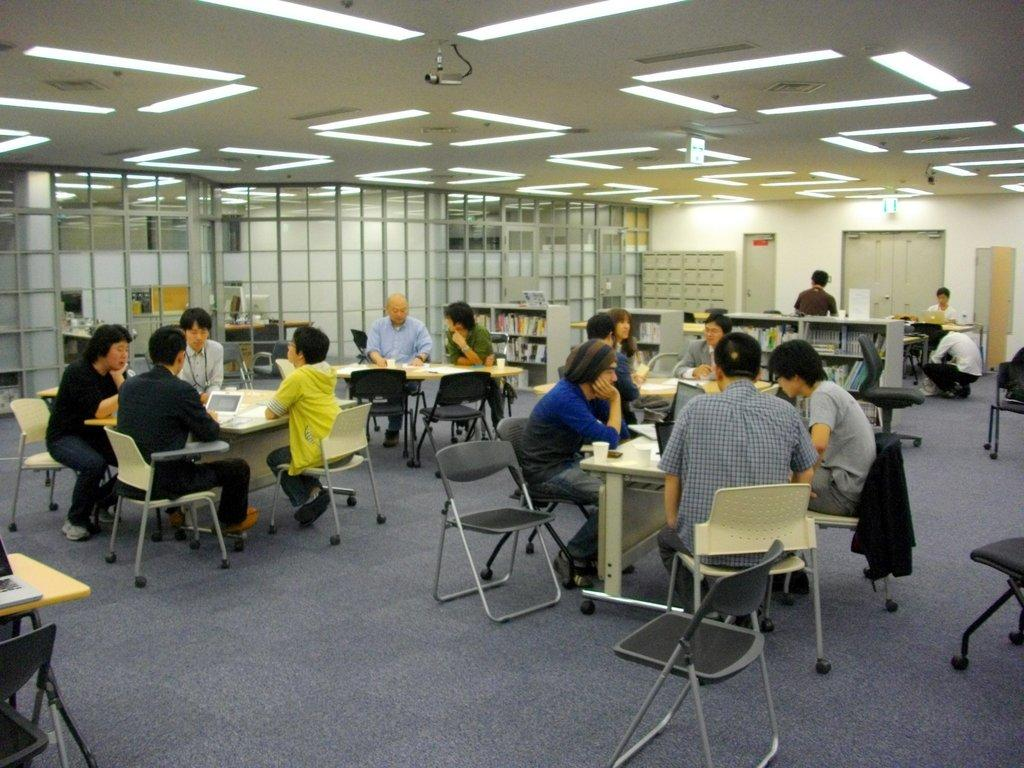What type of structure can be seen in the image? There is a door and a wall in the image. What furniture is present in the image? There are chairs and tables in the image. What are the people in the image doing? There are people sitting on the chairs. How many fowl are visible in the image? There are no fowl present in the image. What form does the door take in the image? The door is a rectangular structure, but it does not have a specific form beyond that. 